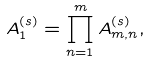<formula> <loc_0><loc_0><loc_500><loc_500>A _ { 1 } ^ { ( s ) } = \prod _ { n = 1 } ^ { m } A _ { m , n } ^ { ( s ) } ,</formula> 